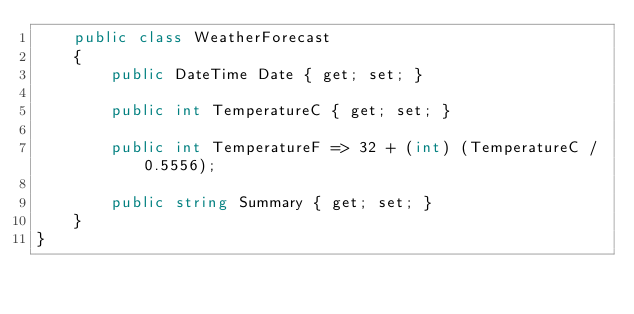Convert code to text. <code><loc_0><loc_0><loc_500><loc_500><_C#_>    public class WeatherForecast
    {
        public DateTime Date { get; set; }

        public int TemperatureC { get; set; }

        public int TemperatureF => 32 + (int) (TemperatureC / 0.5556);

        public string Summary { get; set; }
    }
}</code> 